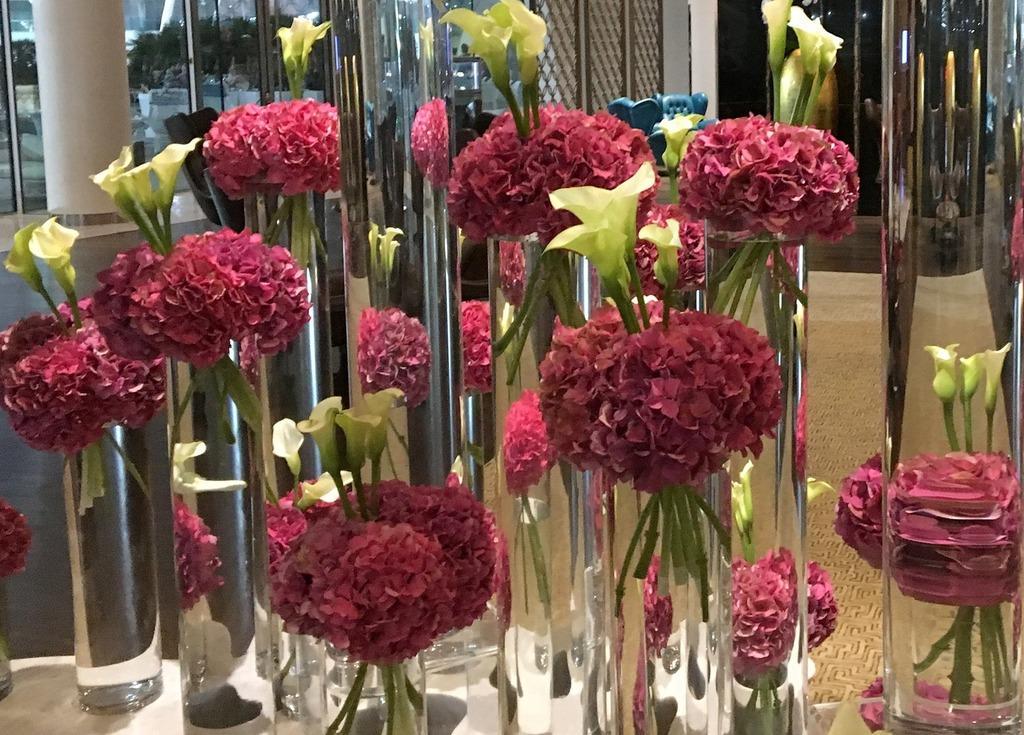How would you summarize this image in a sentence or two? In this image, we can see so many flowers with flower vase and water. These are placed on the white surface. Background we can see glasses, pillar and floor. 